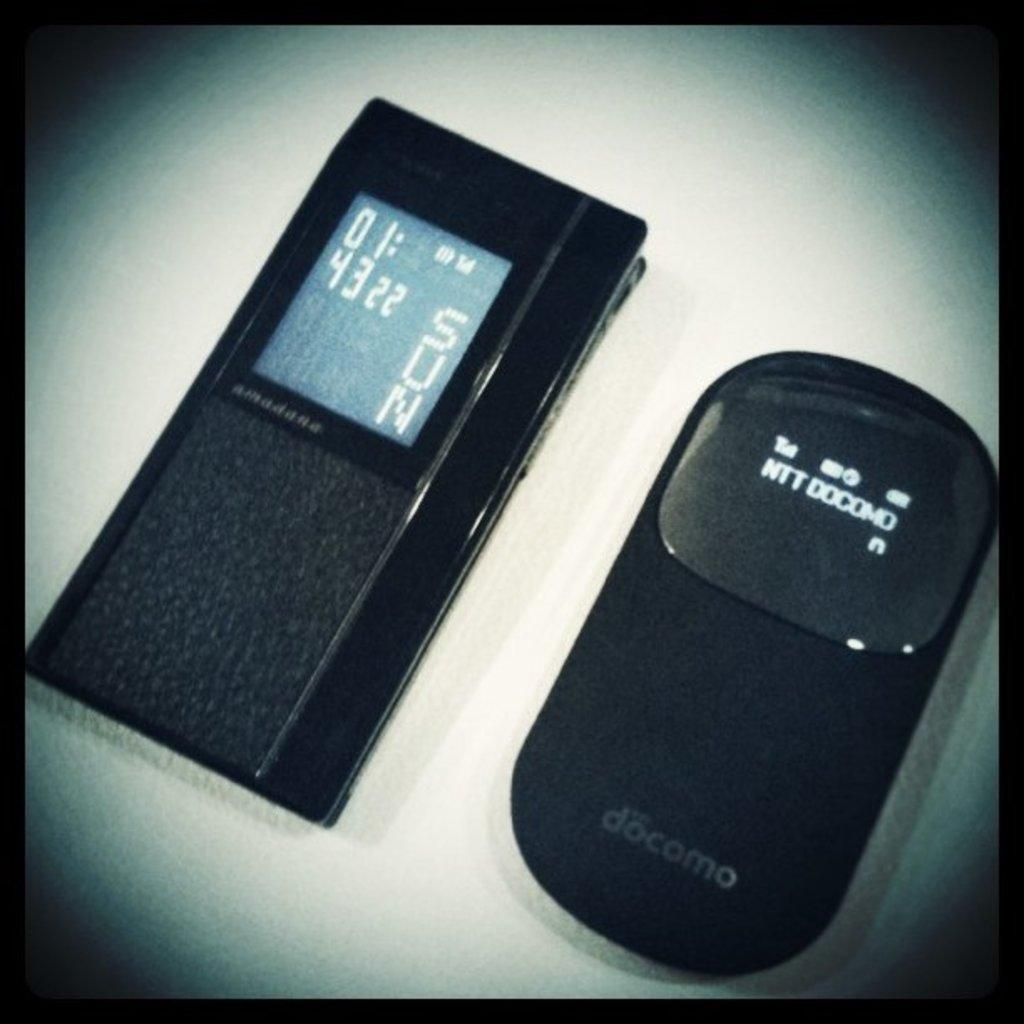<image>
Create a compact narrative representing the image presented. A docomo brand electronic device is next to another electronic device. 